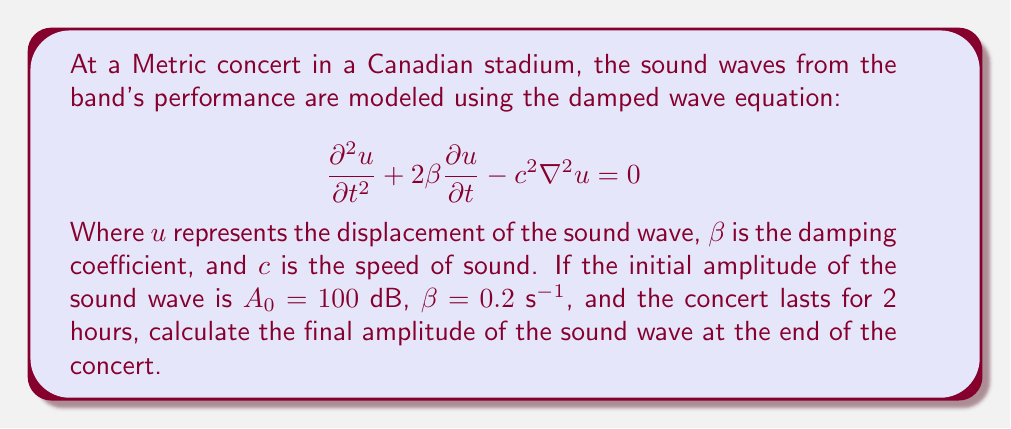Could you help me with this problem? To solve this problem, we'll follow these steps:

1) The damped wave equation given describes the propagation and dissipation of sound waves in the stadium. The solution for the amplitude of a damped wave is given by:

   $$A(t) = A_0 e^{-\beta t}$$

   Where $A_0$ is the initial amplitude and $t$ is time.

2) We're given:
   - Initial amplitude $A_0 = 100$ dB
   - Damping coefficient $\beta = 0.2$ s^(-1)
   - Time $t = 2$ hours = 7200 seconds

3) Let's substitute these values into the equation:

   $$A(7200) = 100 e^{-0.2 \cdot 7200}$$

4) Now, let's calculate:

   $$A(7200) = 100 e^{-1440}$$

5) Using a calculator (as this is a very small number):

   $$A(7200) \approx 100 \cdot (2.973 \times 10^{-626})$$
   $$A(7200) \approx 2.973 \times 10^{-624}$$ dB

6) This extremely small value effectively means that the sound has completely dissipated by the end of the concert.
Answer: $2.973 \times 10^{-624}$ dB (effectively 0 dB) 